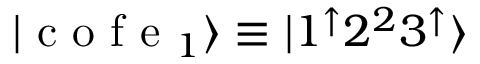<formula> <loc_0><loc_0><loc_500><loc_500>| c o f e _ { 1 } \rangle \equiv | 1 ^ { \uparrow } 2 ^ { 2 } 3 ^ { \uparrow } \rangle</formula> 